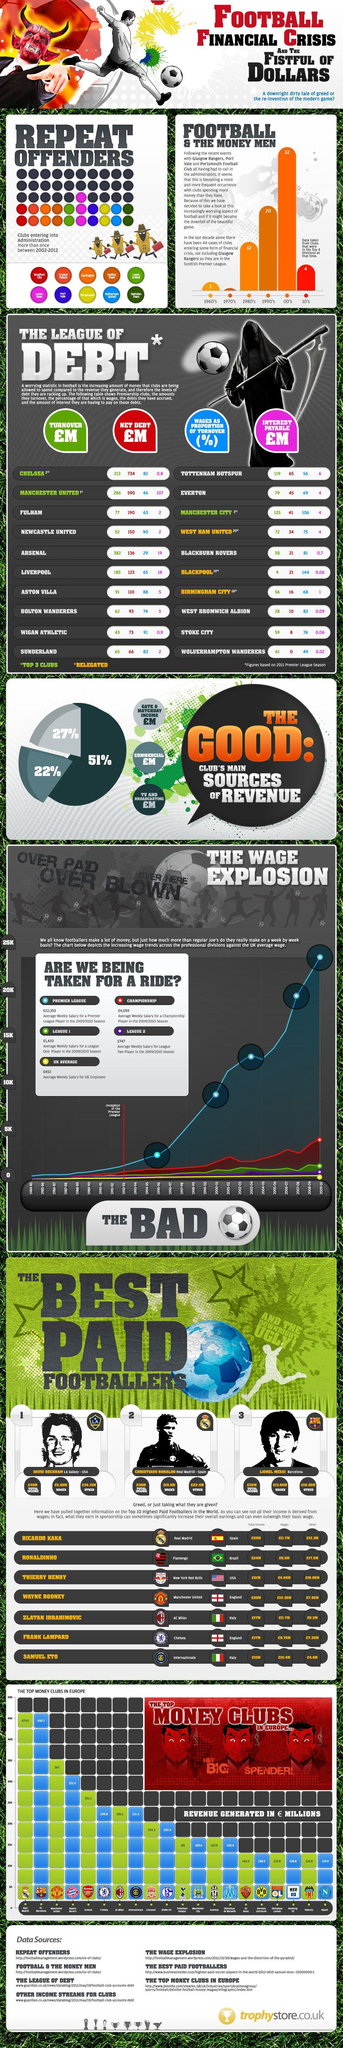Highlight a few significant elements in this photo. Commercial revenue is the least significant source of income for professional football clubs, with gate and matchday revenue, as well as television and broadcasting revenue, generating more income. David Beckham had the highest total income among footballers such as Christiano Ronaldo, Lionel Messi, and himself. Samuel Eto'o, a player, earned revenue from other sources that amounted to 4.8 million pounds. It is estimated that six football clubs, collectively, generate the least amount of revenue in millions of pounds among all clubs in the league. It is confirmed that Lionel Messi is the best paid footballer at FC Barcelona. 